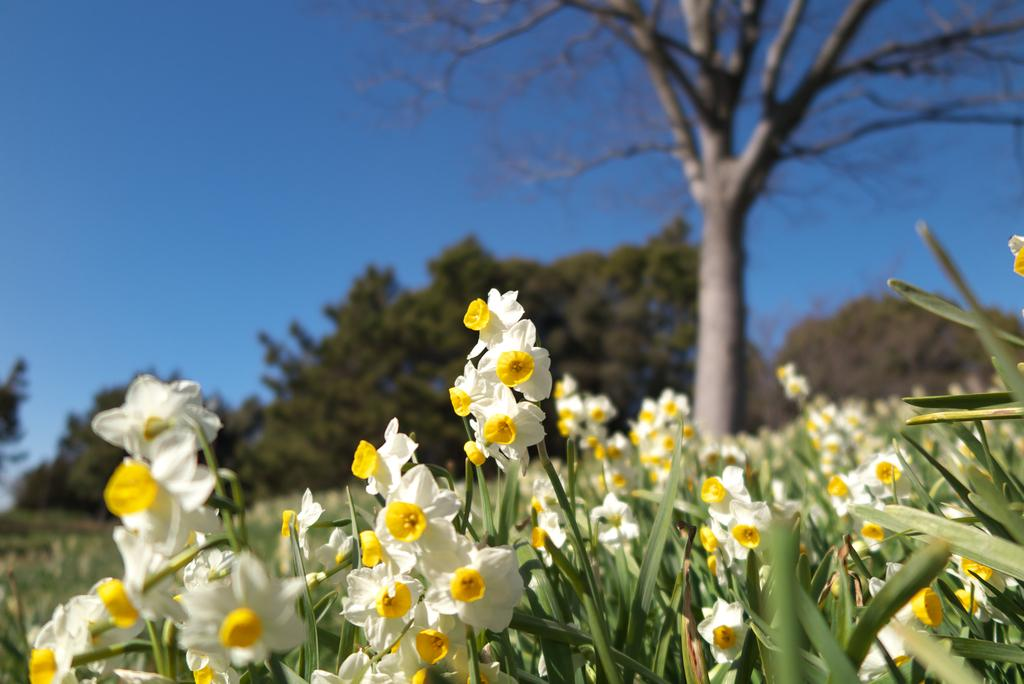What type of vegetation can be seen in the image? There are flower plants and trees in the image. Can you describe the trees in the image? The trees in the image are tall and have leaves. How many types of vegetation are present in the image? There are two types of vegetation present in the image: flower plants and trees. What design can be seen on the veins of the bell in the image? There is no bell or veins present in the image; it features flower plants and trees. 